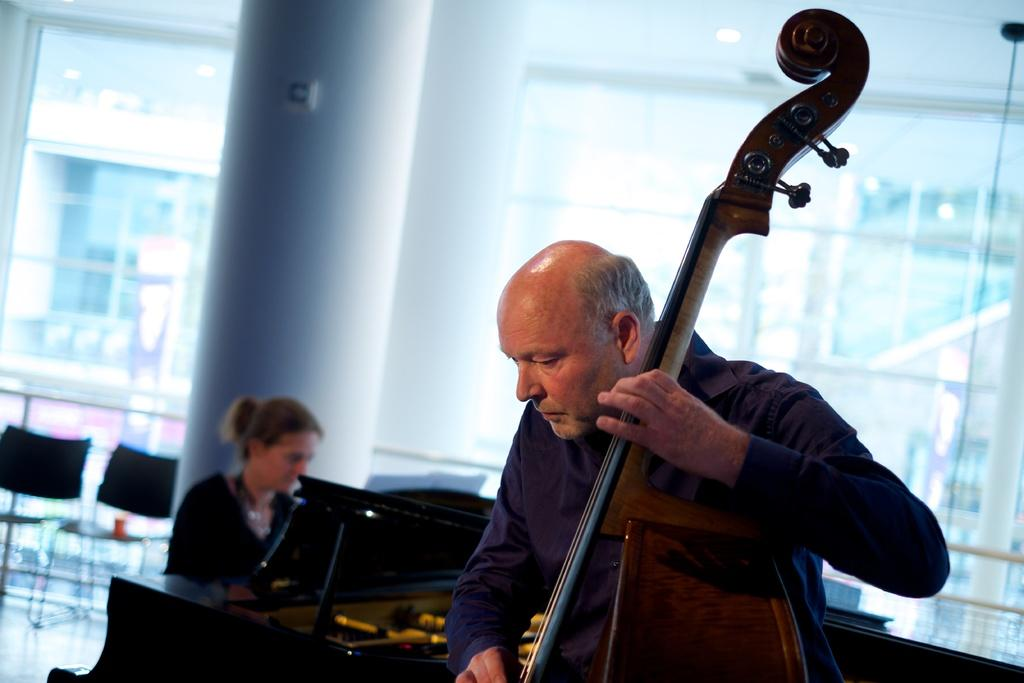What is the man in the image doing? The man is playing a violin. What is the woman in the image doing? The woman is playing a piano. What type of furniture is present in the image? There are chairs in the image. What type of soup is being prepared in the image? There is no soup present in the image; it features a man playing a violin and a woman playing a piano. What discovery was made by the man while playing the violin? There is no mention of a discovery in the image; the man is simply playing the violin. 